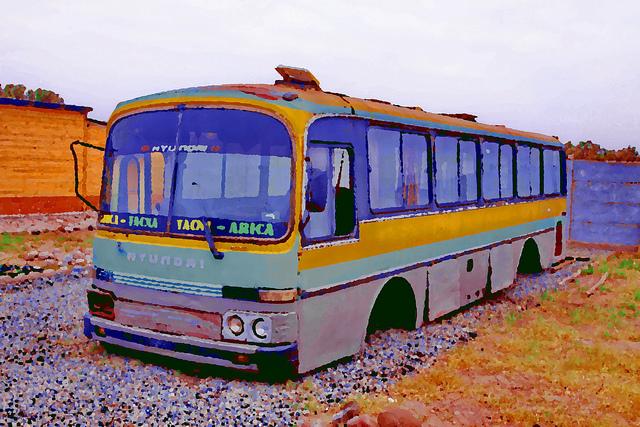Are there people on the bus?
Keep it brief. No. Is this vehicle currently road worthy?
Be succinct. No. Are there any tires on this bus?
Concise answer only. No. How many people on the bus?
Answer briefly. 0. What kind of vehicle is shown?
Concise answer only. Bus. What type of vehicle is here?
Answer briefly. Bus. How can we tell this bus won't be moving anytime soon?
Keep it brief. No wheels. 